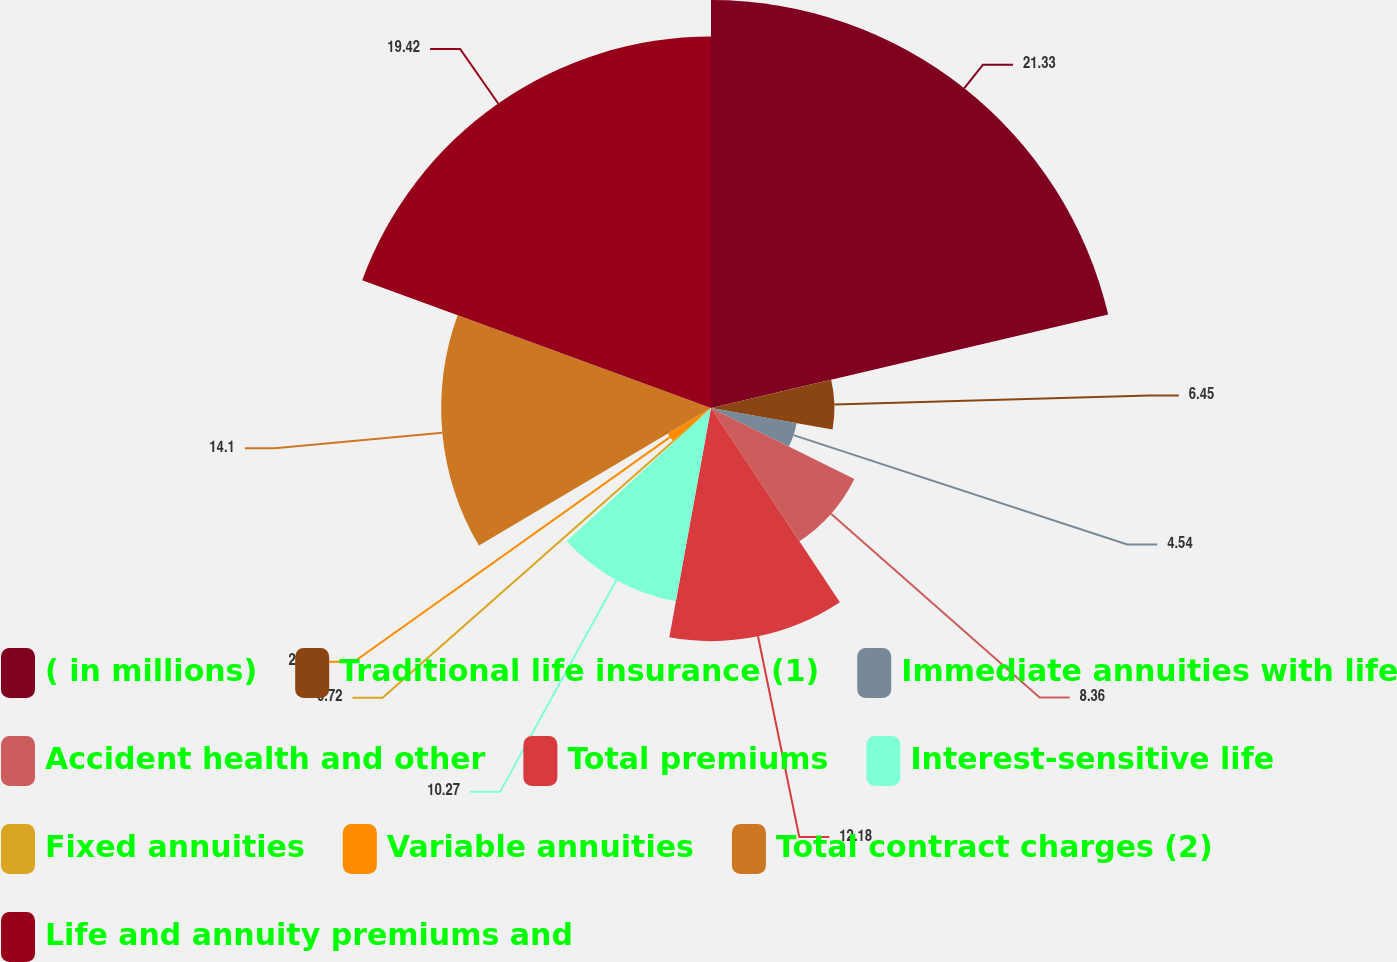Convert chart. <chart><loc_0><loc_0><loc_500><loc_500><pie_chart><fcel>( in millions)<fcel>Traditional life insurance (1)<fcel>Immediate annuities with life<fcel>Accident health and other<fcel>Total premiums<fcel>Interest-sensitive life<fcel>Fixed annuities<fcel>Variable annuities<fcel>Total contract charges (2)<fcel>Life and annuity premiums and<nl><fcel>21.32%<fcel>6.45%<fcel>4.54%<fcel>8.36%<fcel>12.18%<fcel>10.27%<fcel>0.72%<fcel>2.63%<fcel>14.1%<fcel>19.41%<nl></chart> 